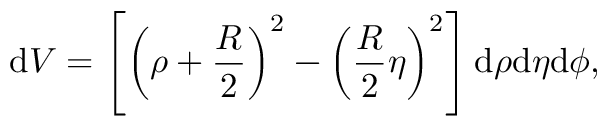<formula> <loc_0><loc_0><loc_500><loc_500>d V = \left [ \left ( \rho + \frac { R } { 2 } \right ) ^ { 2 } - \left ( \frac { R } { 2 } \eta \right ) ^ { 2 } \right ] d \rho d \eta d \phi ,</formula> 